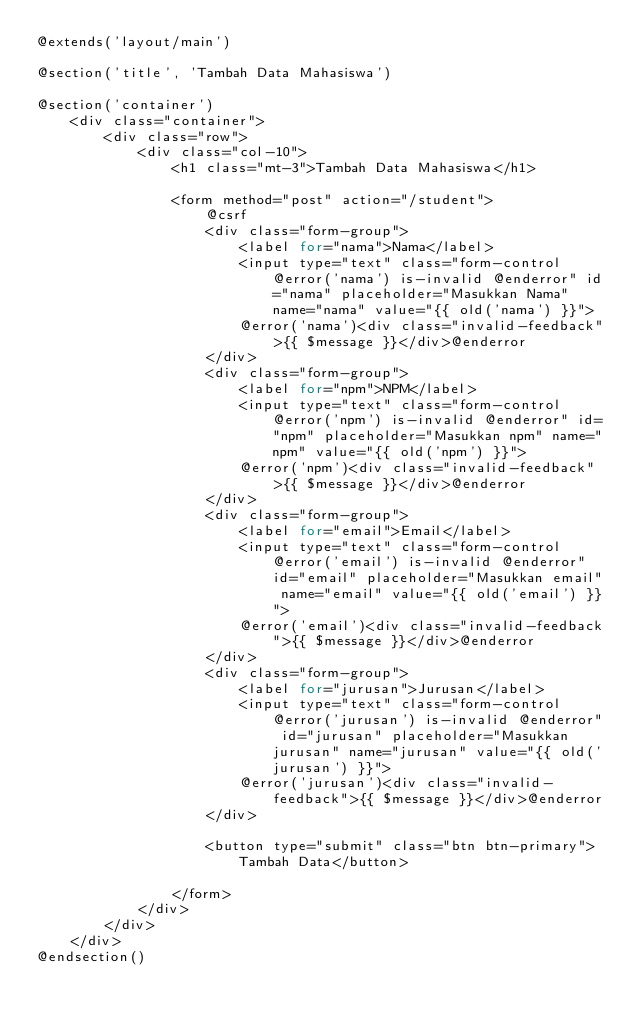<code> <loc_0><loc_0><loc_500><loc_500><_PHP_>@extends('layout/main')

@section('title', 'Tambah Data Mahasiswa')

@section('container')
    <div class="container">
        <div class="row">
            <div class="col-10">
                <h1 class="mt-3">Tambah Data Mahasiswa</h1>

                <form method="post" action="/student">
                    @csrf
                    <div class="form-group">
                        <label for="nama">Nama</label>
                        <input type="text" class="form-control @error('nama') is-invalid @enderror" id="nama" placeholder="Masukkan Nama" name="nama" value="{{ old('nama') }}">
                        @error('nama')<div class="invalid-feedback">{{ $message }}</div>@enderror
                    </div>
                    <div class="form-group">
                        <label for="npm">NPM</label>
                        <input type="text" class="form-control @error('npm') is-invalid @enderror" id="npm" placeholder="Masukkan npm" name="npm" value="{{ old('npm') }}">
                        @error('npm')<div class="invalid-feedback">{{ $message }}</div>@enderror
                    </div>
                    <div class="form-group">
                        <label for="email">Email</label>
                        <input type="text" class="form-control @error('email') is-invalid @enderror" id="email" placeholder="Masukkan email" name="email" value="{{ old('email') }}">
                        @error('email')<div class="invalid-feedback">{{ $message }}</div>@enderror
                    </div>
                    <div class="form-group">
                        <label for="jurusan">Jurusan</label>
                        <input type="text" class="form-control @error('jurusan') is-invalid @enderror" id="jurusan" placeholder="Masukkan jurusan" name="jurusan" value="{{ old('jurusan') }}">
                        @error('jurusan')<div class="invalid-feedback">{{ $message }}</div>@enderror
                    </div>

                    <button type="submit" class="btn btn-primary">Tambah Data</button>
                
                </form>
            </div>
        </div>
    </div>
@endsection()</code> 